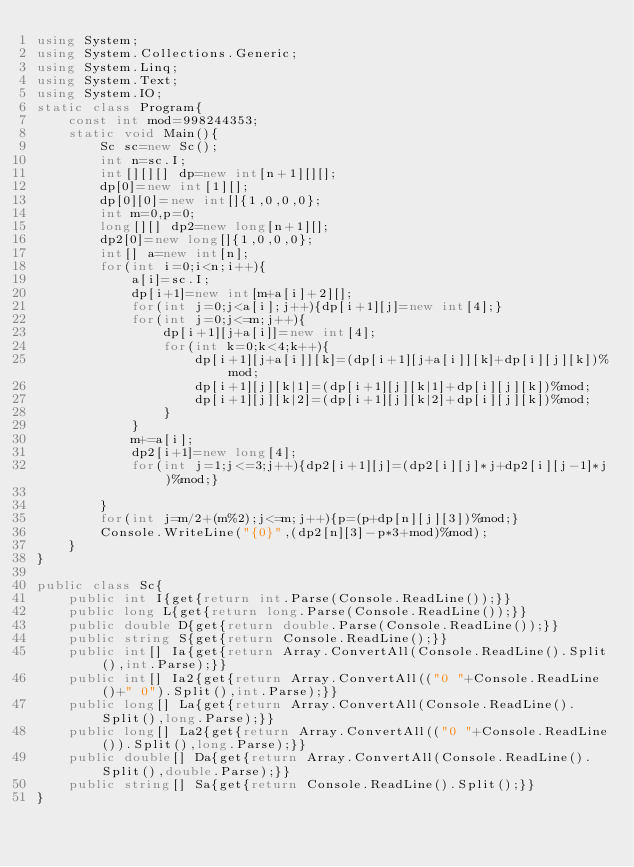<code> <loc_0><loc_0><loc_500><loc_500><_C#_>using System;
using System.Collections.Generic;
using System.Linq;
using System.Text;
using System.IO;
static class Program{
	const int mod=998244353;
	static void Main(){
		Sc sc=new Sc();
		int n=sc.I;
		int[][][] dp=new int[n+1][][];
		dp[0]=new int[1][];
		dp[0][0]=new int[]{1,0,0,0};
		int m=0,p=0;
		long[][] dp2=new long[n+1][];
		dp2[0]=new long[]{1,0,0,0};
		int[] a=new int[n];
		for(int i=0;i<n;i++){
			a[i]=sc.I;
			dp[i+1]=new int[m+a[i]+2][];
			for(int j=0;j<a[i];j++){dp[i+1][j]=new int[4];}
			for(int j=0;j<=m;j++){
				dp[i+1][j+a[i]]=new int[4];
				for(int k=0;k<4;k++){
					dp[i+1][j+a[i]][k]=(dp[i+1][j+a[i]][k]+dp[i][j][k])%mod;
					dp[i+1][j][k|1]=(dp[i+1][j][k|1]+dp[i][j][k])%mod;
					dp[i+1][j][k|2]=(dp[i+1][j][k|2]+dp[i][j][k])%mod;
				}
			}
			m+=a[i];
			dp2[i+1]=new long[4];
			for(int j=1;j<=3;j++){dp2[i+1][j]=(dp2[i][j]*j+dp2[i][j-1]*j)%mod;}

		}
		for(int j=m/2+(m%2);j<=m;j++){p=(p+dp[n][j][3])%mod;}
		Console.WriteLine("{0}",(dp2[n][3]-p*3+mod)%mod);
	}
}

public class Sc{
	public int I{get{return int.Parse(Console.ReadLine());}}
	public long L{get{return long.Parse(Console.ReadLine());}}
	public double D{get{return double.Parse(Console.ReadLine());}}
	public string S{get{return Console.ReadLine();}}
	public int[] Ia{get{return Array.ConvertAll(Console.ReadLine().Split(),int.Parse);}}
	public int[] Ia2{get{return Array.ConvertAll(("0 "+Console.ReadLine()+" 0").Split(),int.Parse);}}
	public long[] La{get{return Array.ConvertAll(Console.ReadLine().Split(),long.Parse);}}
	public long[] La2{get{return Array.ConvertAll(("0 "+Console.ReadLine()).Split(),long.Parse);}}
	public double[] Da{get{return Array.ConvertAll(Console.ReadLine().Split(),double.Parse);}}
	public string[] Sa{get{return Console.ReadLine().Split();}}
}</code> 